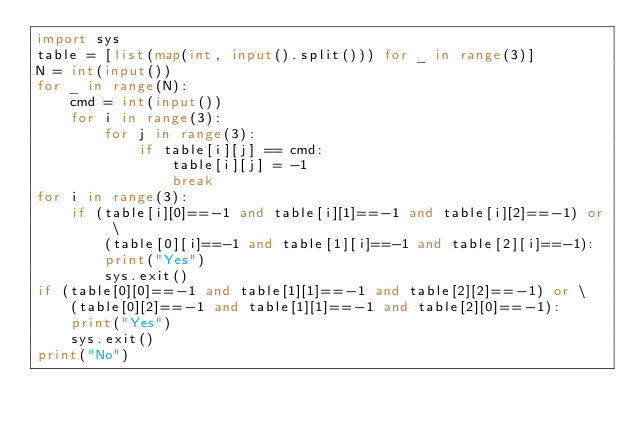Convert code to text. <code><loc_0><loc_0><loc_500><loc_500><_Python_>import sys
table = [list(map(int, input().split())) for _ in range(3)]
N = int(input())
for _ in range(N):
    cmd = int(input())
    for i in range(3):
        for j in range(3):
            if table[i][j] == cmd:
                table[i][j] = -1
                break
for i in range(3):
    if (table[i][0]==-1 and table[i][1]==-1 and table[i][2]==-1) or \
        (table[0][i]==-1 and table[1][i]==-1 and table[2][i]==-1):
        print("Yes")
        sys.exit()
if (table[0][0]==-1 and table[1][1]==-1 and table[2][2]==-1) or \
    (table[0][2]==-1 and table[1][1]==-1 and table[2][0]==-1):
    print("Yes")
    sys.exit()
print("No")</code> 